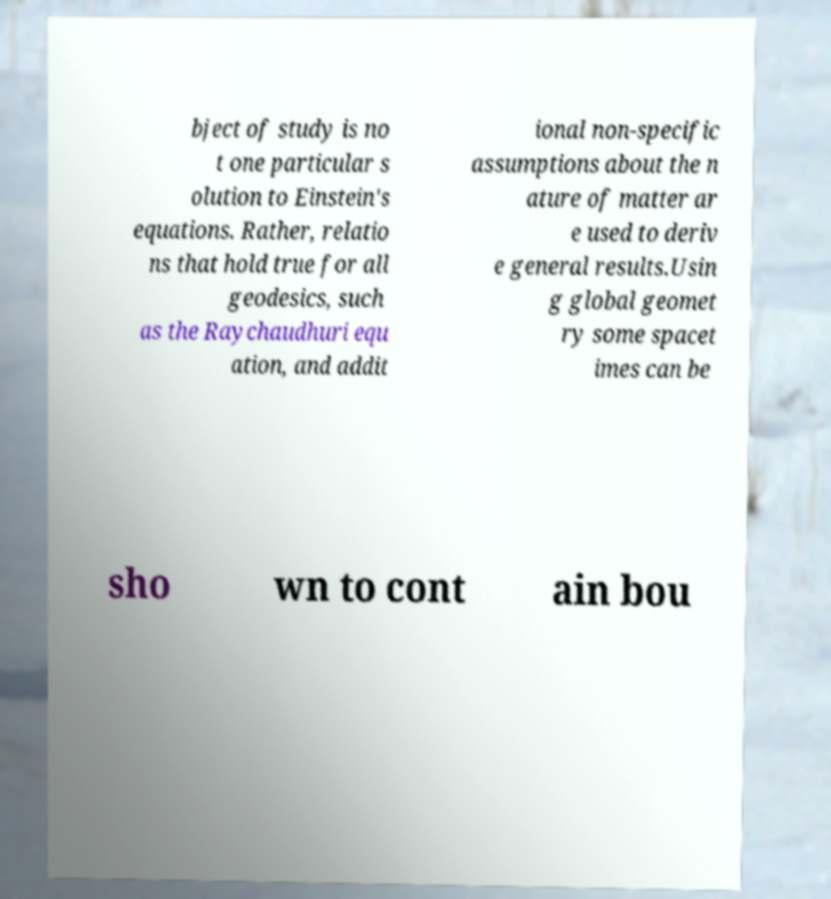Please read and relay the text visible in this image. What does it say? bject of study is no t one particular s olution to Einstein's equations. Rather, relatio ns that hold true for all geodesics, such as the Raychaudhuri equ ation, and addit ional non-specific assumptions about the n ature of matter ar e used to deriv e general results.Usin g global geomet ry some spacet imes can be sho wn to cont ain bou 